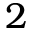Convert formula to latex. <formula><loc_0><loc_0><loc_500><loc_500>2</formula> 